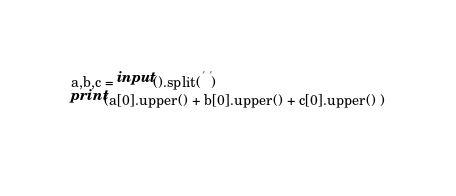Convert code to text. <code><loc_0><loc_0><loc_500><loc_500><_Python_>a,b,c = input().split(' ')
print(a[0].upper() + b[0].upper() + c[0].upper() )
  </code> 